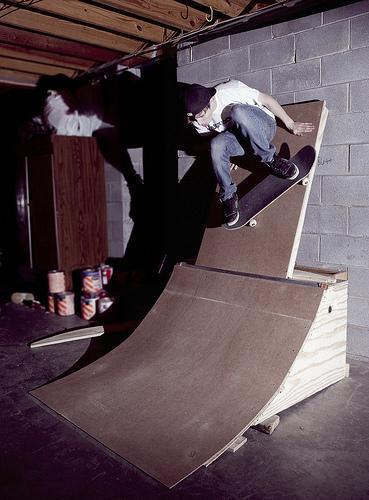How many people are there?
Give a very brief answer. 1. 